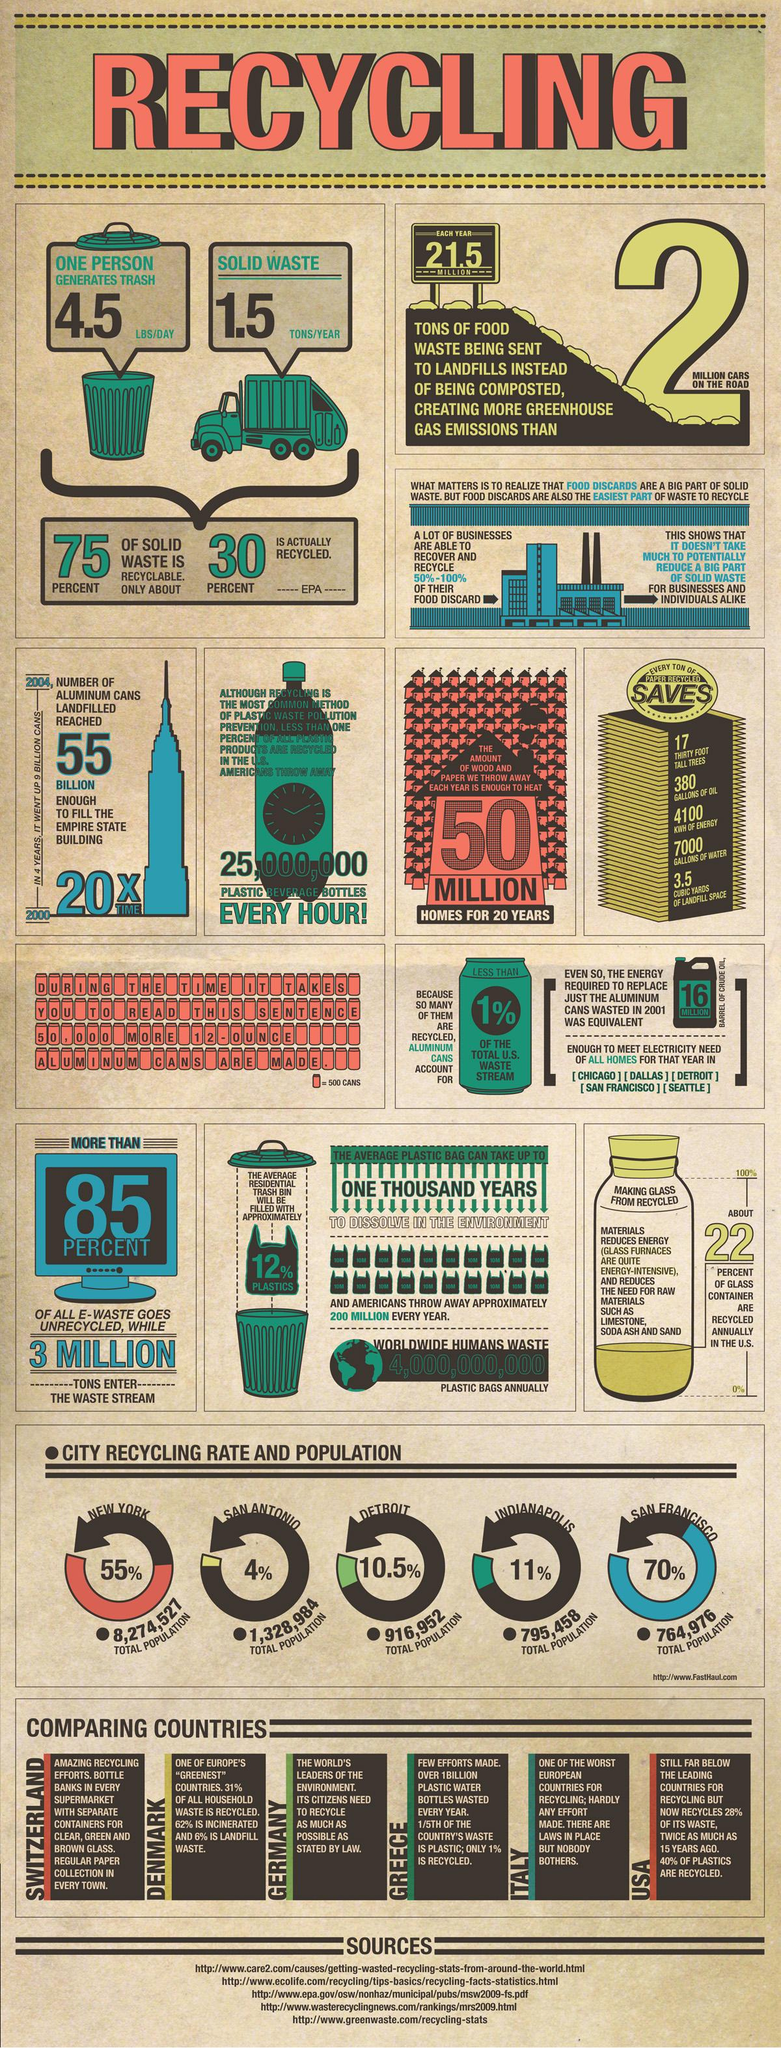Identify some key points in this picture. San Antonio is the city with the second highest population and the lowest percentage of recycling. Detroit, San Antonio, and New York are all cities with a significant population. However, it is New York that has the highest total population, making it the largest city of the three. San Francisco has the highest recycling rate among the cities of New York, Detroit, and San Francisco. 40% of waste is still available for recycling. Three countries, Switzerland, Denmark, and Germany, are known for their excellence in waste management. 